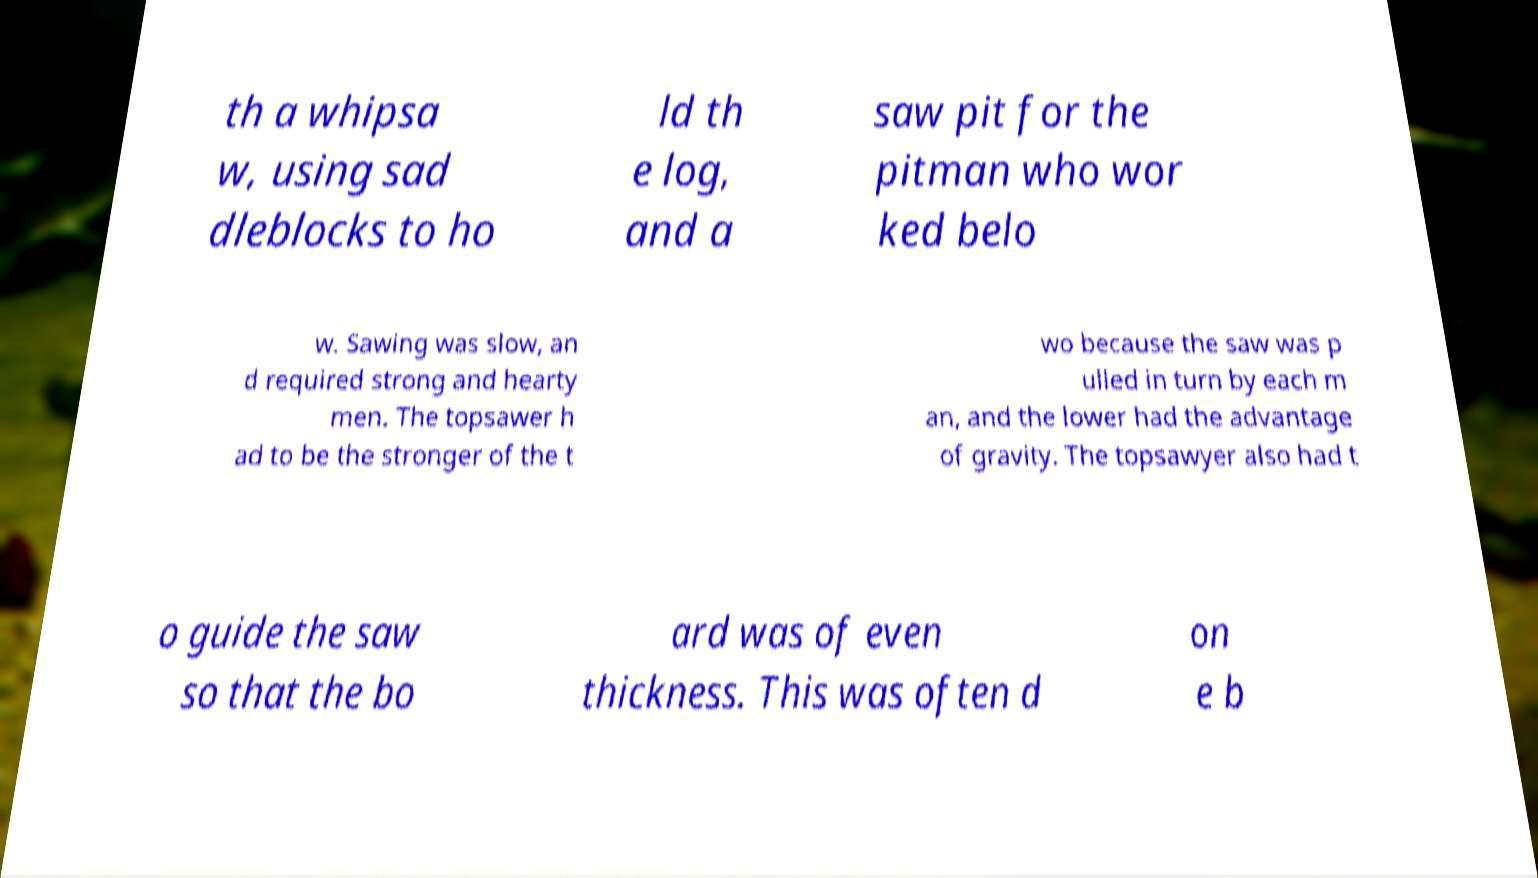Please identify and transcribe the text found in this image. th a whipsa w, using sad dleblocks to ho ld th e log, and a saw pit for the pitman who wor ked belo w. Sawing was slow, an d required strong and hearty men. The topsawer h ad to be the stronger of the t wo because the saw was p ulled in turn by each m an, and the lower had the advantage of gravity. The topsawyer also had t o guide the saw so that the bo ard was of even thickness. This was often d on e b 